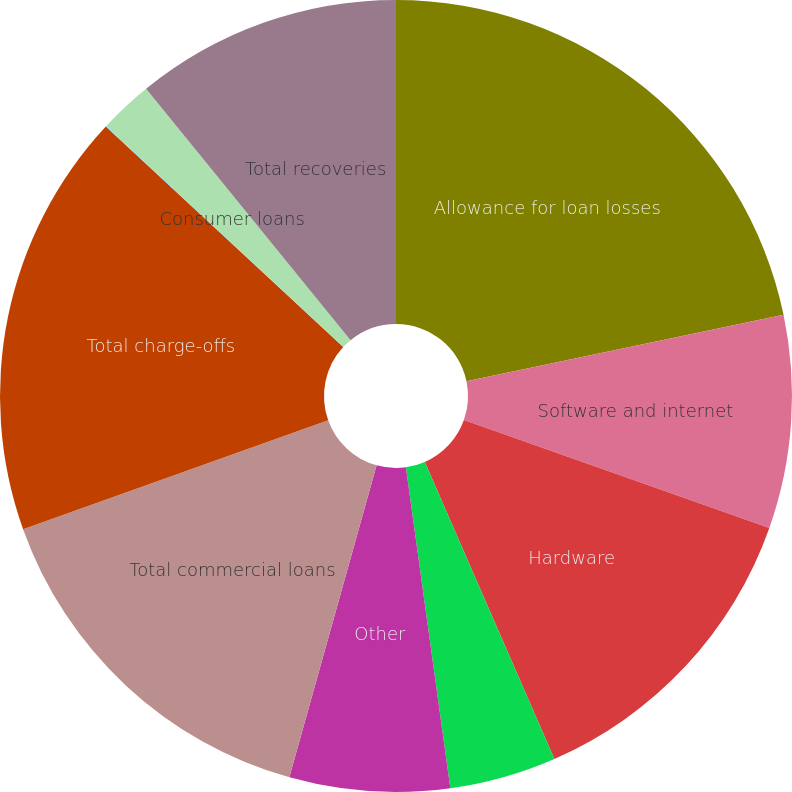Convert chart to OTSL. <chart><loc_0><loc_0><loc_500><loc_500><pie_chart><fcel>Allowance for loan losses<fcel>Software and internet<fcel>Hardware<fcel>Life science/healthcare<fcel>Other<fcel>Total commercial loans<fcel>Total charge-offs<fcel>Premium wine<fcel>Consumer loans<fcel>Total recoveries<nl><fcel>21.71%<fcel>8.7%<fcel>13.04%<fcel>4.36%<fcel>6.53%<fcel>15.2%<fcel>17.37%<fcel>0.03%<fcel>2.19%<fcel>10.87%<nl></chart> 